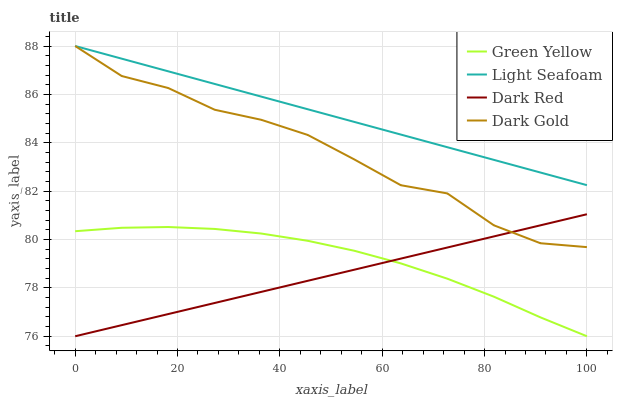Does Dark Red have the minimum area under the curve?
Answer yes or no. Yes. Does Light Seafoam have the maximum area under the curve?
Answer yes or no. Yes. Does Green Yellow have the minimum area under the curve?
Answer yes or no. No. Does Green Yellow have the maximum area under the curve?
Answer yes or no. No. Is Light Seafoam the smoothest?
Answer yes or no. Yes. Is Dark Gold the roughest?
Answer yes or no. Yes. Is Green Yellow the smoothest?
Answer yes or no. No. Is Green Yellow the roughest?
Answer yes or no. No. Does Light Seafoam have the lowest value?
Answer yes or no. No. Does Dark Gold have the highest value?
Answer yes or no. Yes. Does Green Yellow have the highest value?
Answer yes or no. No. Is Green Yellow less than Dark Gold?
Answer yes or no. Yes. Is Dark Gold greater than Green Yellow?
Answer yes or no. Yes. Does Dark Red intersect Dark Gold?
Answer yes or no. Yes. Is Dark Red less than Dark Gold?
Answer yes or no. No. Is Dark Red greater than Dark Gold?
Answer yes or no. No. Does Green Yellow intersect Dark Gold?
Answer yes or no. No. 